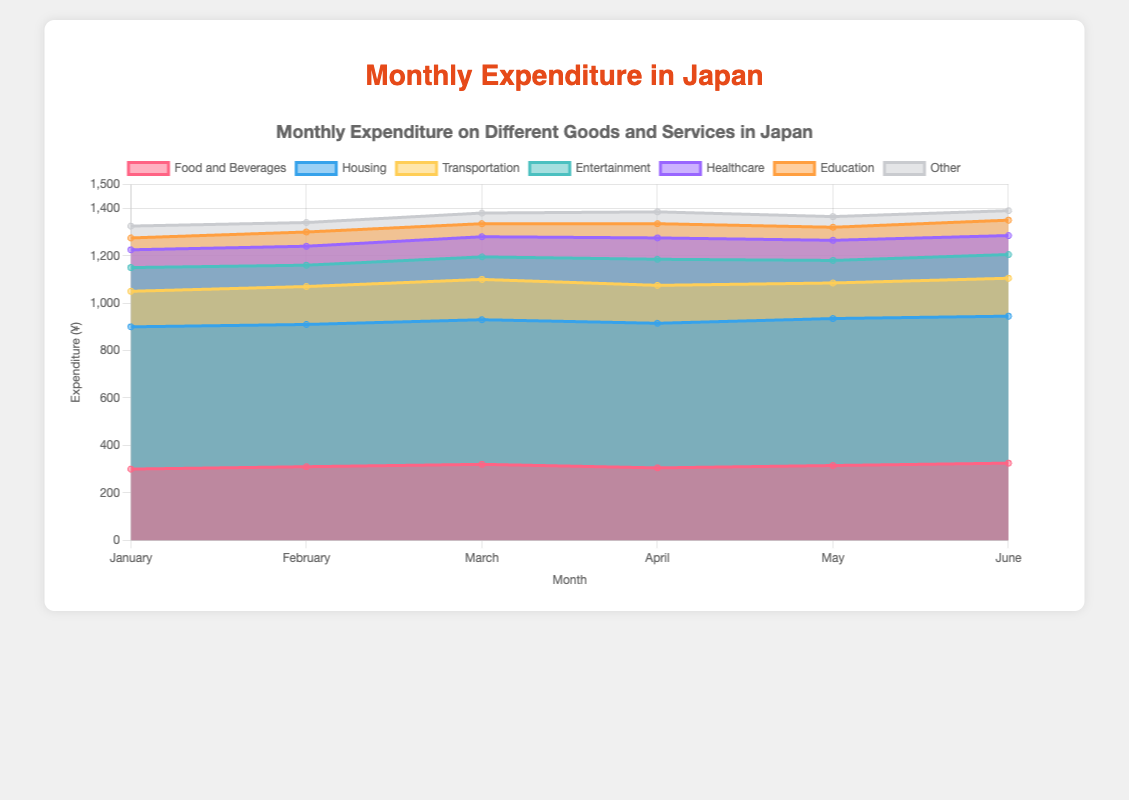What is the title of the chart? The title of the chart is usually displayed at the top. By looking at the top of the chart, we see it reads "Monthly Expenditure on Different Goods and Services in Japan".
Answer: "Monthly Expenditure on Different Goods and Services in Japan" Which month has the highest expenditure on "Food and Beverages"? To determine the month with the highest expenditure on "Food and Beverages", we look at the dataset corresponding to "Food and Beverages" and compare the values for each month. June has the highest value, which is 325.
Answer: June What is the average monthly expenditure on "Transportation" from January to June? To find the average, sum the expenditure values for "Transportation" from January to June [(150 + 160 + 170 + 160 + 150 + 160) = 950] and divide by the number of months (6). So, 950 / 6 = 158.33.
Answer: 158.33 Which category had the most consistent expenditure from January to June? A category with the most consistent expenditure will have the least variation in its values over the months. "Housing" is a clear candidate, where the values remain fairly constant around 600-620.
Answer: Housing How does the expenditure on "Entertainment" in February compare to that in April? By comparing the values, expenditure on "Entertainment" in February is 90 and in April is 110. Therefore, April has a higher expenditure on "Entertainment" compared to February.
Answer: April What was the total expenditure on "Education" throughout the six months? Sum the expenditure values on "Education" for each month: 50 + 60 + 55 + 60 + 55 + 65 = 345.
Answer: 345 In which month did "Healthcare" expenditures peak, and what was the value? "Healthcare" expenditures peaked in April, where the value is 90.
Answer: April, 90 Which category showed the largest increase from January to June? The largest increase can be determined by comparing the January and June values for each category: "Food and Beverages" increased from 300 to 325, showing the largest increase of 25.
Answer: Food and Beverages Compare the total expenditures in January to the total expenditures in June. Calculate the total expenditure for both months: January (300 + 600 + 150 + 100 + 75 + 50 + 50 = 1325) and June (325 + 620 + 160 + 100 + 80 + 65 + 40 = 1390). June has higher total expenditures than January.
Answer: June What is the combined expenditure on "Other" for the first three months? Sum the expenditure values for "Other" for January, February, and March: 50 + 40 + 45 = 135.
Answer: 135 